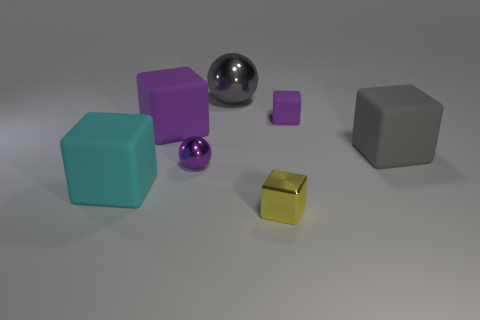Subtract all blue cubes. Subtract all blue spheres. How many cubes are left? 5 Add 1 tiny metallic objects. How many objects exist? 8 Subtract all cubes. How many objects are left? 2 Subtract 0 brown spheres. How many objects are left? 7 Subtract all purple metallic spheres. Subtract all big metallic objects. How many objects are left? 5 Add 3 small purple metallic balls. How many small purple metallic balls are left? 4 Add 3 purple objects. How many purple objects exist? 6 